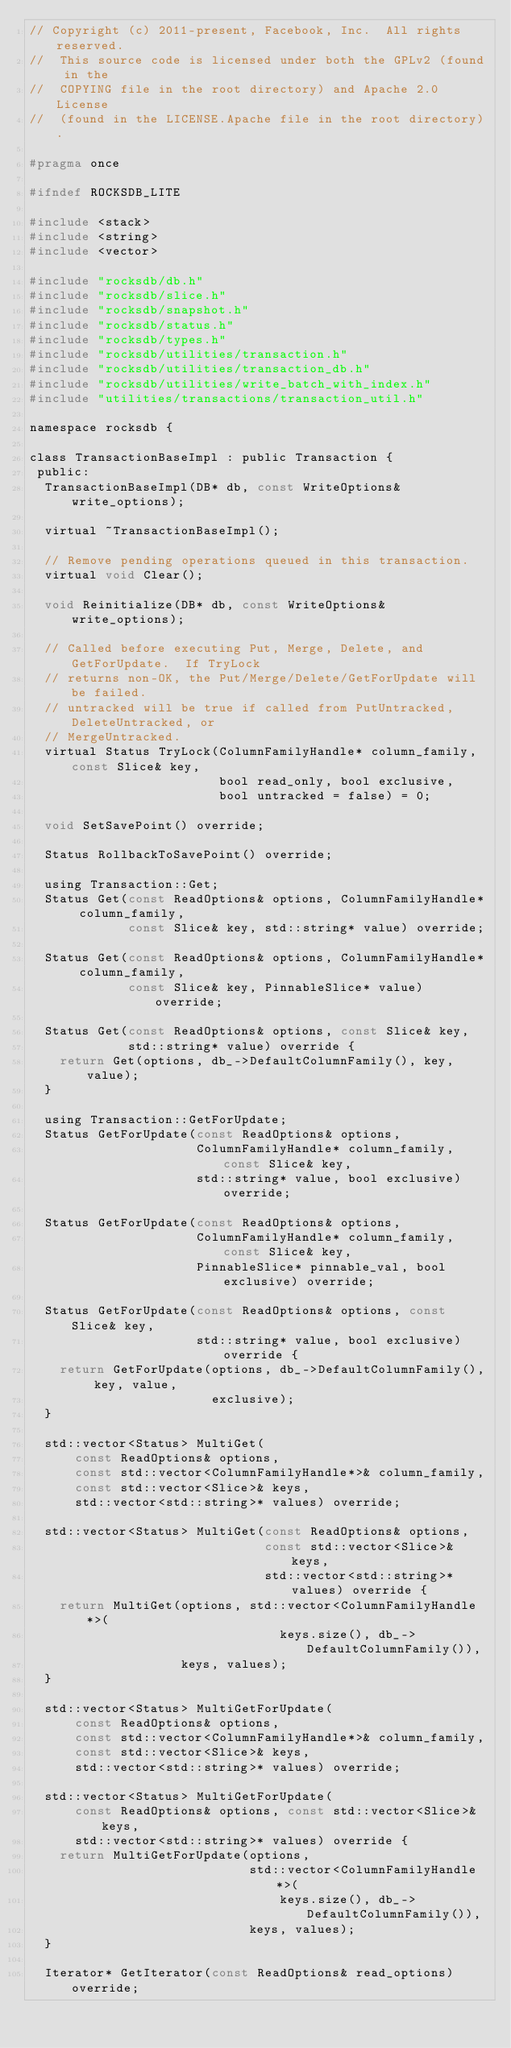<code> <loc_0><loc_0><loc_500><loc_500><_C_>// Copyright (c) 2011-present, Facebook, Inc.  All rights reserved.
//  This source code is licensed under both the GPLv2 (found in the
//  COPYING file in the root directory) and Apache 2.0 License
//  (found in the LICENSE.Apache file in the root directory).

#pragma once

#ifndef ROCKSDB_LITE

#include <stack>
#include <string>
#include <vector>

#include "rocksdb/db.h"
#include "rocksdb/slice.h"
#include "rocksdb/snapshot.h"
#include "rocksdb/status.h"
#include "rocksdb/types.h"
#include "rocksdb/utilities/transaction.h"
#include "rocksdb/utilities/transaction_db.h"
#include "rocksdb/utilities/write_batch_with_index.h"
#include "utilities/transactions/transaction_util.h"

namespace rocksdb {

class TransactionBaseImpl : public Transaction {
 public:
  TransactionBaseImpl(DB* db, const WriteOptions& write_options);

  virtual ~TransactionBaseImpl();

  // Remove pending operations queued in this transaction.
  virtual void Clear();

  void Reinitialize(DB* db, const WriteOptions& write_options);

  // Called before executing Put, Merge, Delete, and GetForUpdate.  If TryLock
  // returns non-OK, the Put/Merge/Delete/GetForUpdate will be failed.
  // untracked will be true if called from PutUntracked, DeleteUntracked, or
  // MergeUntracked.
  virtual Status TryLock(ColumnFamilyHandle* column_family, const Slice& key,
                         bool read_only, bool exclusive,
                         bool untracked = false) = 0;

  void SetSavePoint() override;

  Status RollbackToSavePoint() override;

  using Transaction::Get;
  Status Get(const ReadOptions& options, ColumnFamilyHandle* column_family,
             const Slice& key, std::string* value) override;

  Status Get(const ReadOptions& options, ColumnFamilyHandle* column_family,
             const Slice& key, PinnableSlice* value) override;

  Status Get(const ReadOptions& options, const Slice& key,
             std::string* value) override {
    return Get(options, db_->DefaultColumnFamily(), key, value);
  }

  using Transaction::GetForUpdate;
  Status GetForUpdate(const ReadOptions& options,
                      ColumnFamilyHandle* column_family, const Slice& key,
                      std::string* value, bool exclusive) override;

  Status GetForUpdate(const ReadOptions& options,
                      ColumnFamilyHandle* column_family, const Slice& key,
                      PinnableSlice* pinnable_val, bool exclusive) override;

  Status GetForUpdate(const ReadOptions& options, const Slice& key,
                      std::string* value, bool exclusive) override {
    return GetForUpdate(options, db_->DefaultColumnFamily(), key, value,
                        exclusive);
  }

  std::vector<Status> MultiGet(
      const ReadOptions& options,
      const std::vector<ColumnFamilyHandle*>& column_family,
      const std::vector<Slice>& keys,
      std::vector<std::string>* values) override;

  std::vector<Status> MultiGet(const ReadOptions& options,
                               const std::vector<Slice>& keys,
                               std::vector<std::string>* values) override {
    return MultiGet(options, std::vector<ColumnFamilyHandle*>(
                                 keys.size(), db_->DefaultColumnFamily()),
                    keys, values);
  }

  std::vector<Status> MultiGetForUpdate(
      const ReadOptions& options,
      const std::vector<ColumnFamilyHandle*>& column_family,
      const std::vector<Slice>& keys,
      std::vector<std::string>* values) override;

  std::vector<Status> MultiGetForUpdate(
      const ReadOptions& options, const std::vector<Slice>& keys,
      std::vector<std::string>* values) override {
    return MultiGetForUpdate(options,
                             std::vector<ColumnFamilyHandle*>(
                                 keys.size(), db_->DefaultColumnFamily()),
                             keys, values);
  }

  Iterator* GetIterator(const ReadOptions& read_options) override;</code> 